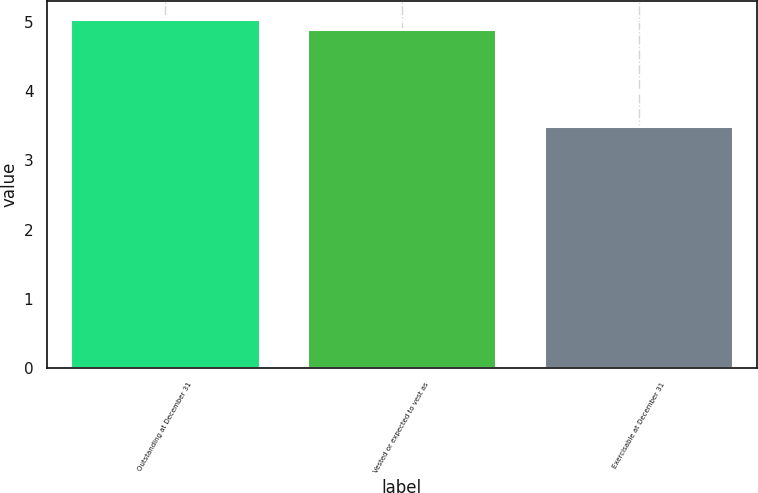<chart> <loc_0><loc_0><loc_500><loc_500><bar_chart><fcel>Outstanding at December 31<fcel>Vested or expected to vest as<fcel>Exercisable at December 31<nl><fcel>5.05<fcel>4.9<fcel>3.5<nl></chart> 